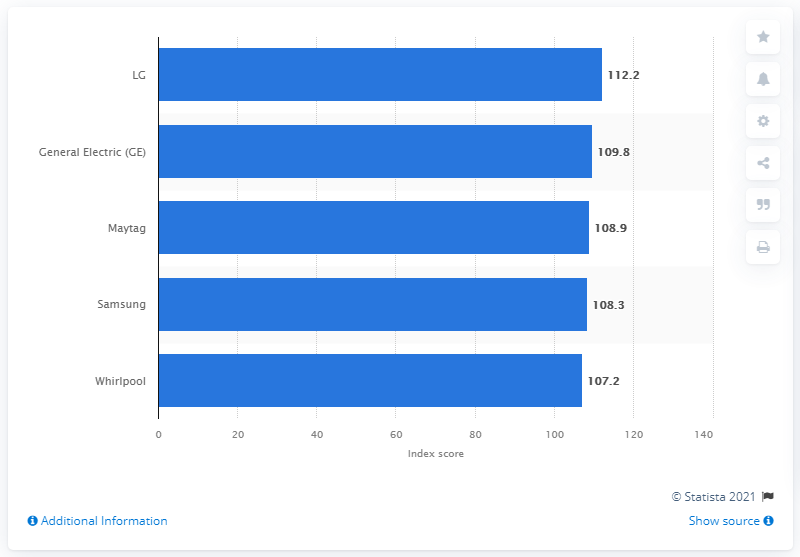Specify some key components in this picture. The index score of LG was 112.2. 